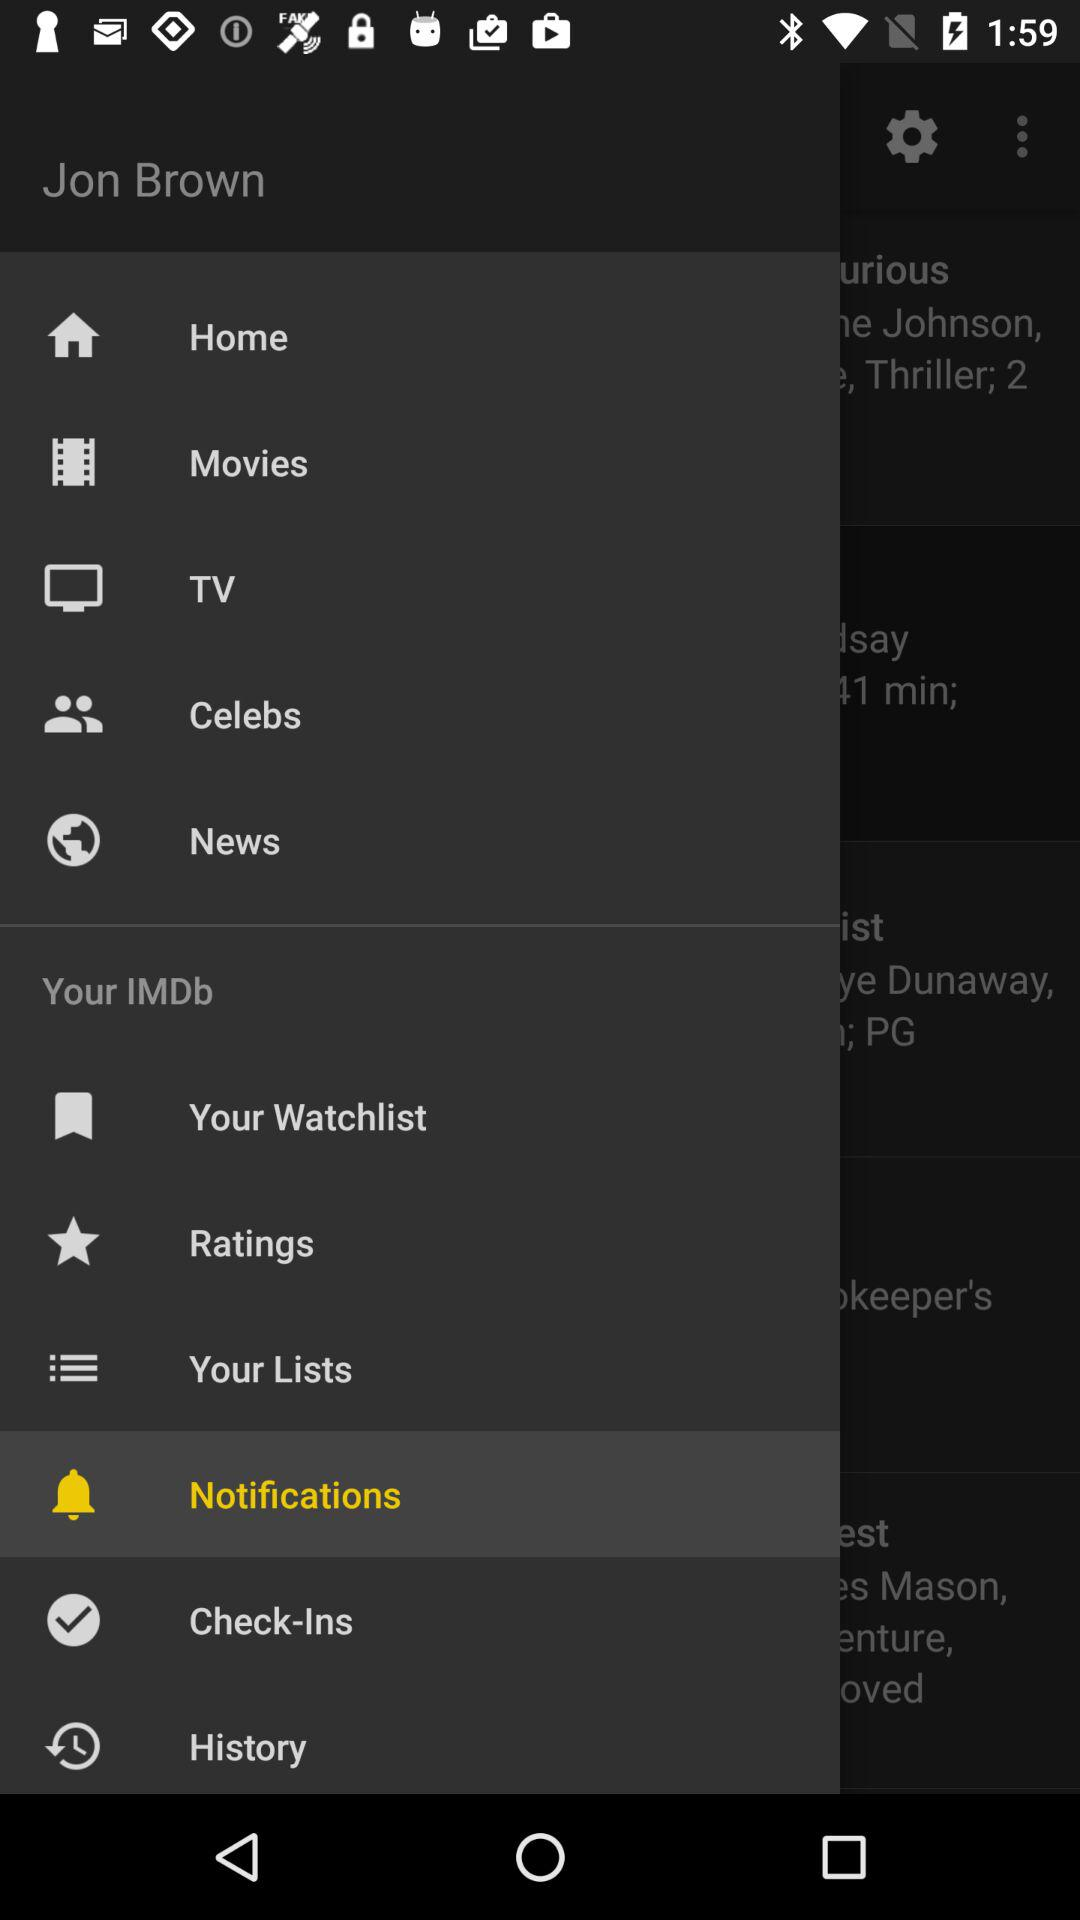Which item is selected? The selected item is "Notifications". 